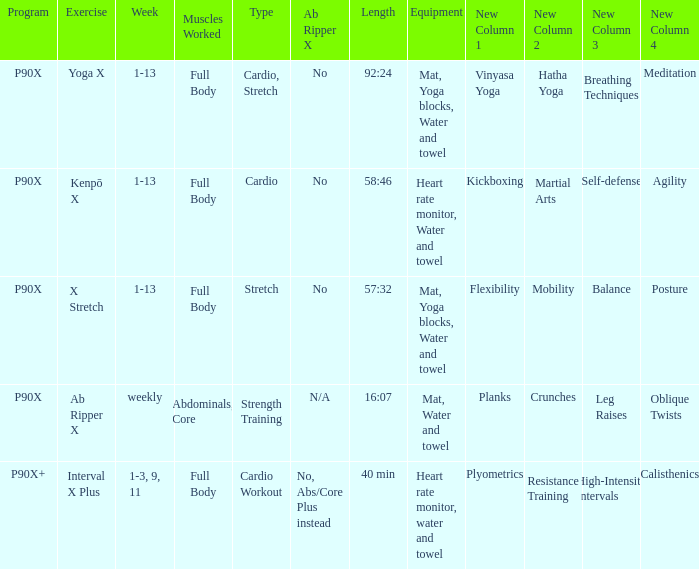What is the ab ripper x when the length is 92:24? No. Would you be able to parse every entry in this table? {'header': ['Program', 'Exercise', 'Week', 'Muscles Worked', 'Type', 'Ab Ripper X', 'Length', 'Equipment', 'New Column 1', 'New Column 2', 'New Column 3', 'New Column 4'], 'rows': [['P90X', 'Yoga X', '1-13', 'Full Body', 'Cardio, Stretch', 'No', '92:24', 'Mat, Yoga blocks, Water and towel', 'Vinyasa Yoga', 'Hatha Yoga', 'Breathing Techniques', 'Meditation'], ['P90X', 'Kenpō X', '1-13', 'Full Body', 'Cardio', 'No', '58:46', 'Heart rate monitor, Water and towel', 'Kickboxing', 'Martial Arts', 'Self-defense', 'Agility'], ['P90X', 'X Stretch', '1-13', 'Full Body', 'Stretch', 'No', '57:32', 'Mat, Yoga blocks, Water and towel', 'Flexibility', 'Mobility', 'Balance', 'Posture'], ['P90X', 'Ab Ripper X', 'weekly', 'Abdominals, Core', 'Strength Training', 'N/A', '16:07', 'Mat, Water and towel', 'Planks', 'Crunches', 'Leg Raises', 'Oblique Twists'], ['P90X+', 'Interval X Plus', '1-3, 9, 11', 'Full Body', 'Cardio Workout', 'No, Abs/Core Plus instead', '40 min', 'Heart rate monitor, water and towel', 'Plyometrics', 'Resistance Training', 'High-Intensity Intervals', 'Calisthenics']]} 